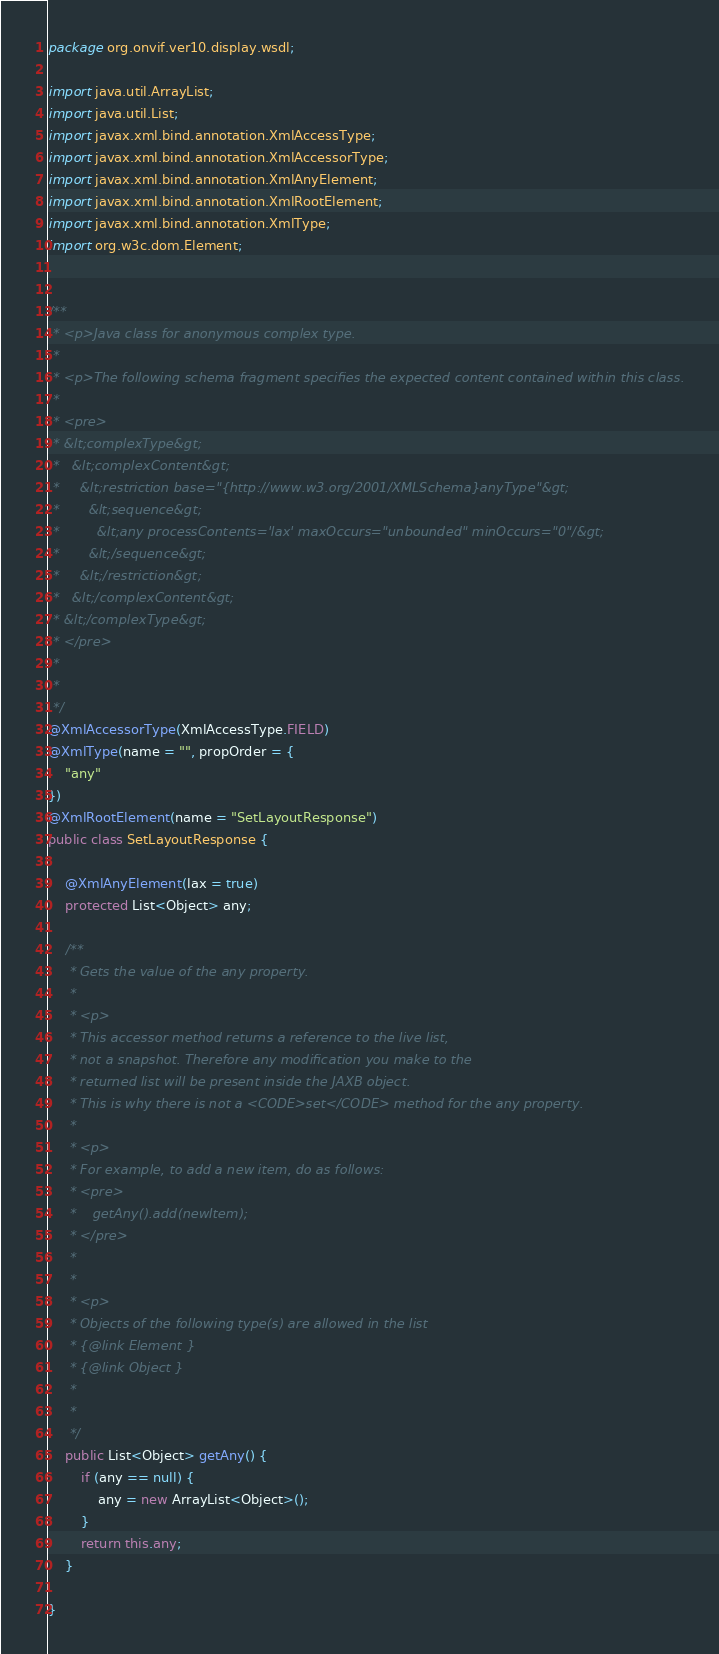<code> <loc_0><loc_0><loc_500><loc_500><_Java_>
package org.onvif.ver10.display.wsdl;

import java.util.ArrayList;
import java.util.List;
import javax.xml.bind.annotation.XmlAccessType;
import javax.xml.bind.annotation.XmlAccessorType;
import javax.xml.bind.annotation.XmlAnyElement;
import javax.xml.bind.annotation.XmlRootElement;
import javax.xml.bind.annotation.XmlType;
import org.w3c.dom.Element;


/**
 * <p>Java class for anonymous complex type.
 * 
 * <p>The following schema fragment specifies the expected content contained within this class.
 * 
 * <pre>
 * &lt;complexType&gt;
 *   &lt;complexContent&gt;
 *     &lt;restriction base="{http://www.w3.org/2001/XMLSchema}anyType"&gt;
 *       &lt;sequence&gt;
 *         &lt;any processContents='lax' maxOccurs="unbounded" minOccurs="0"/&gt;
 *       &lt;/sequence&gt;
 *     &lt;/restriction&gt;
 *   &lt;/complexContent&gt;
 * &lt;/complexType&gt;
 * </pre>
 * 
 * 
 */
@XmlAccessorType(XmlAccessType.FIELD)
@XmlType(name = "", propOrder = {
    "any"
})
@XmlRootElement(name = "SetLayoutResponse")
public class SetLayoutResponse {

    @XmlAnyElement(lax = true)
    protected List<Object> any;

    /**
     * Gets the value of the any property.
     * 
     * <p>
     * This accessor method returns a reference to the live list,
     * not a snapshot. Therefore any modification you make to the
     * returned list will be present inside the JAXB object.
     * This is why there is not a <CODE>set</CODE> method for the any property.
     * 
     * <p>
     * For example, to add a new item, do as follows:
     * <pre>
     *    getAny().add(newItem);
     * </pre>
     * 
     * 
     * <p>
     * Objects of the following type(s) are allowed in the list
     * {@link Element }
     * {@link Object }
     * 
     * 
     */
    public List<Object> getAny() {
        if (any == null) {
            any = new ArrayList<Object>();
        }
        return this.any;
    }

}
</code> 